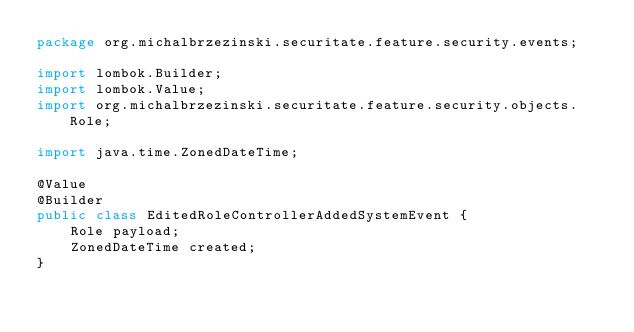Convert code to text. <code><loc_0><loc_0><loc_500><loc_500><_Java_>package org.michalbrzezinski.securitate.feature.security.events;

import lombok.Builder;
import lombok.Value;
import org.michalbrzezinski.securitate.feature.security.objects.Role;

import java.time.ZonedDateTime;

@Value
@Builder
public class EditedRoleControllerAddedSystemEvent {
    Role payload;
    ZonedDateTime created;
}
</code> 